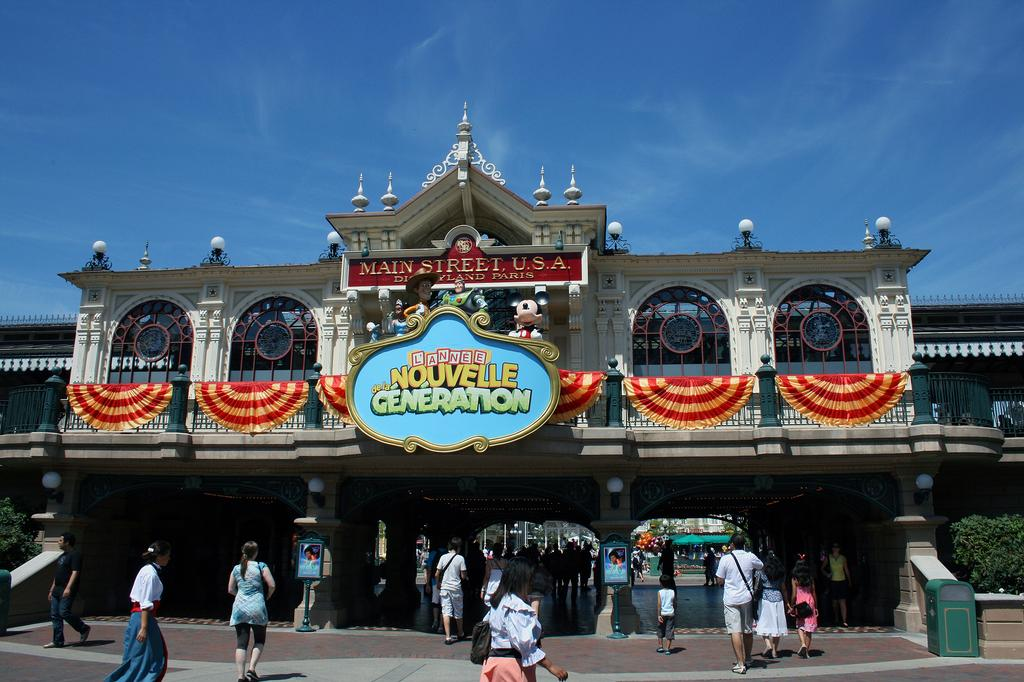What is the main subject in the center of the image? There is a building in the center of the image. What are the people at the bottom of the image doing? There are many people walking at the bottom of the image. What type of vegetation is on the right side of the image? There is a bush on the right side of the image. What can be seen in the background of the image? The sky is visible in the background of the image. What type of disease is being treated at the building in the image? There is no indication of a disease or any medical treatment in the image; it simply shows a building and people walking. 